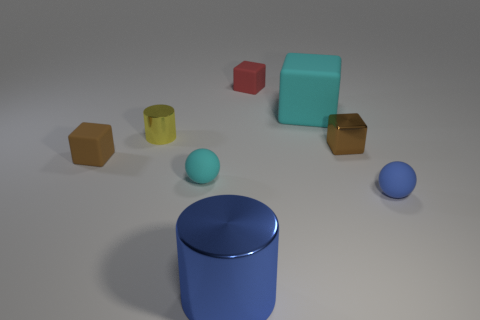There is a thing that is the same color as the large cylinder; what material is it?
Make the answer very short. Rubber. How many tiny balls have the same color as the big block?
Give a very brief answer. 1. What number of yellow cylinders are to the right of the small brown thing that is to the left of the tiny metallic cylinder?
Keep it short and to the point. 1. There is a matte object that is both behind the small cyan rubber ball and right of the red block; how big is it?
Provide a short and direct response. Large. How many metallic objects are either blue cylinders or cyan objects?
Your answer should be compact. 1. What is the big cyan thing made of?
Your answer should be compact. Rubber. What material is the ball that is in front of the small sphere that is behind the tiny object that is in front of the cyan ball?
Your response must be concise. Rubber. What shape is the other metal thing that is the same size as the yellow metallic object?
Keep it short and to the point. Cube. What number of objects are small red cylinders or tiny objects in front of the tiny yellow object?
Keep it short and to the point. 4. Is the material of the big object that is in front of the tiny brown rubber object the same as the small brown object that is on the right side of the tiny red matte block?
Ensure brevity in your answer.  Yes. 